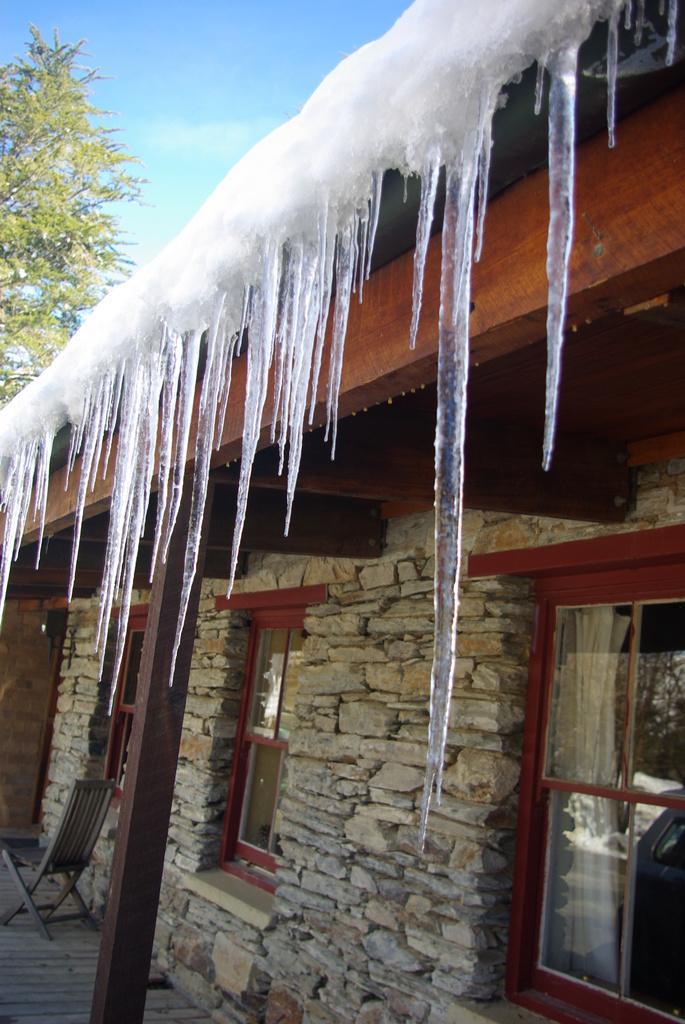Can you describe this image briefly? In this image there is the sky towards the top of the image, there is a tree towards the left of the image, there is a house towards the right of the image, there is an ice on the house, there is a wall, there are windows, there is a curtain, there is floor towards the bottom of the image, there is a chair towards the left of the image, there is a pillar towards the bottom of the image. 